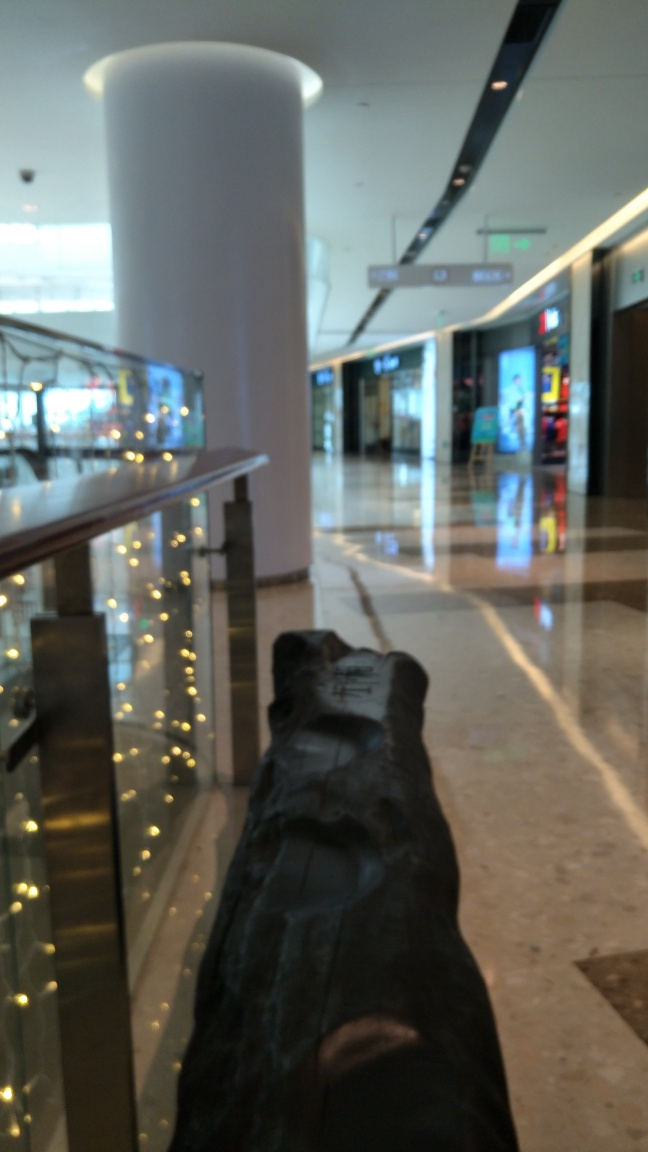What could improve the image quality? Improving the image quality could involve adjusting the focus to ensure the foreground is as sharp as the background, as well as correcting the exposure to achieve a more even lighting throughout the scene. 